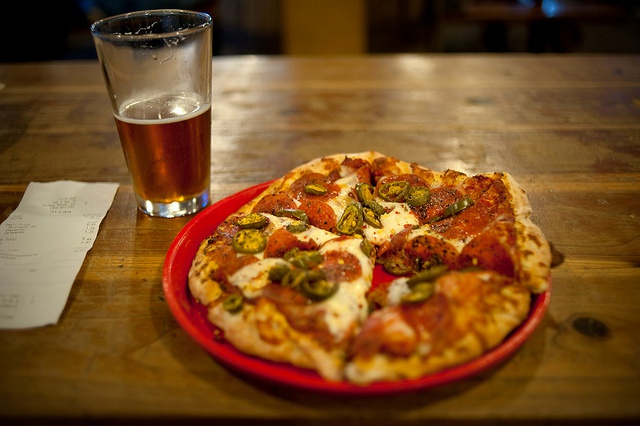Describe the objects in this image and their specific colors. I can see dining table in maroon, black, olive, and tan tones, pizza in black, brown, maroon, and orange tones, cup in black, maroon, and tan tones, and pizza in black, red, maroon, orange, and tan tones in this image. 